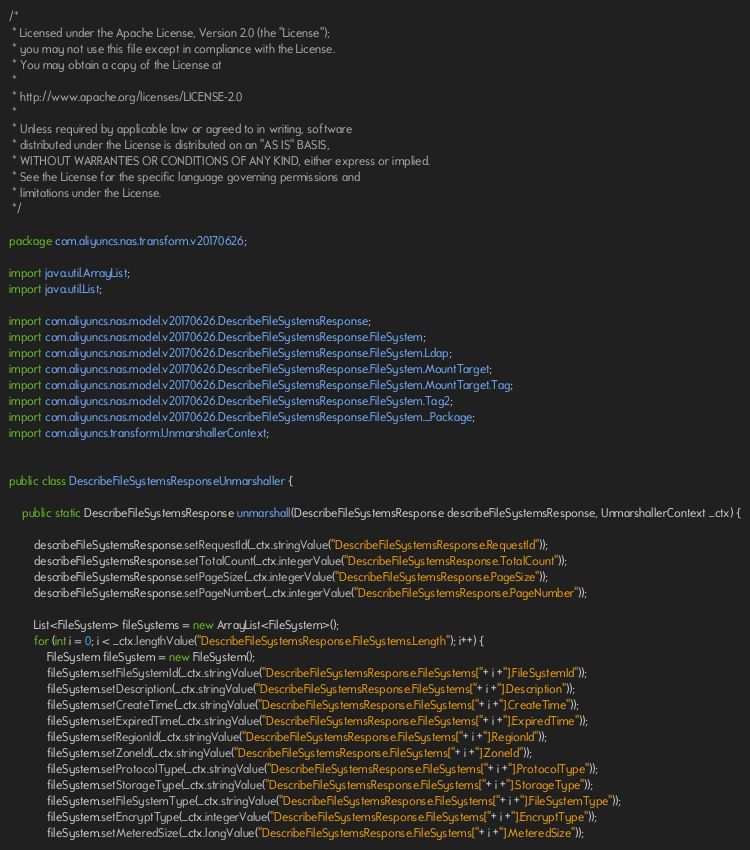Convert code to text. <code><loc_0><loc_0><loc_500><loc_500><_Java_>/*
 * Licensed under the Apache License, Version 2.0 (the "License");
 * you may not use this file except in compliance with the License.
 * You may obtain a copy of the License at
 *
 * http://www.apache.org/licenses/LICENSE-2.0
 *
 * Unless required by applicable law or agreed to in writing, software
 * distributed under the License is distributed on an "AS IS" BASIS,
 * WITHOUT WARRANTIES OR CONDITIONS OF ANY KIND, either express or implied.
 * See the License for the specific language governing permissions and
 * limitations under the License.
 */

package com.aliyuncs.nas.transform.v20170626;

import java.util.ArrayList;
import java.util.List;

import com.aliyuncs.nas.model.v20170626.DescribeFileSystemsResponse;
import com.aliyuncs.nas.model.v20170626.DescribeFileSystemsResponse.FileSystem;
import com.aliyuncs.nas.model.v20170626.DescribeFileSystemsResponse.FileSystem.Ldap;
import com.aliyuncs.nas.model.v20170626.DescribeFileSystemsResponse.FileSystem.MountTarget;
import com.aliyuncs.nas.model.v20170626.DescribeFileSystemsResponse.FileSystem.MountTarget.Tag;
import com.aliyuncs.nas.model.v20170626.DescribeFileSystemsResponse.FileSystem.Tag2;
import com.aliyuncs.nas.model.v20170626.DescribeFileSystemsResponse.FileSystem._Package;
import com.aliyuncs.transform.UnmarshallerContext;


public class DescribeFileSystemsResponseUnmarshaller {

	public static DescribeFileSystemsResponse unmarshall(DescribeFileSystemsResponse describeFileSystemsResponse, UnmarshallerContext _ctx) {
		
		describeFileSystemsResponse.setRequestId(_ctx.stringValue("DescribeFileSystemsResponse.RequestId"));
		describeFileSystemsResponse.setTotalCount(_ctx.integerValue("DescribeFileSystemsResponse.TotalCount"));
		describeFileSystemsResponse.setPageSize(_ctx.integerValue("DescribeFileSystemsResponse.PageSize"));
		describeFileSystemsResponse.setPageNumber(_ctx.integerValue("DescribeFileSystemsResponse.PageNumber"));

		List<FileSystem> fileSystems = new ArrayList<FileSystem>();
		for (int i = 0; i < _ctx.lengthValue("DescribeFileSystemsResponse.FileSystems.Length"); i++) {
			FileSystem fileSystem = new FileSystem();
			fileSystem.setFileSystemId(_ctx.stringValue("DescribeFileSystemsResponse.FileSystems["+ i +"].FileSystemId"));
			fileSystem.setDescription(_ctx.stringValue("DescribeFileSystemsResponse.FileSystems["+ i +"].Description"));
			fileSystem.setCreateTime(_ctx.stringValue("DescribeFileSystemsResponse.FileSystems["+ i +"].CreateTime"));
			fileSystem.setExpiredTime(_ctx.stringValue("DescribeFileSystemsResponse.FileSystems["+ i +"].ExpiredTime"));
			fileSystem.setRegionId(_ctx.stringValue("DescribeFileSystemsResponse.FileSystems["+ i +"].RegionId"));
			fileSystem.setZoneId(_ctx.stringValue("DescribeFileSystemsResponse.FileSystems["+ i +"].ZoneId"));
			fileSystem.setProtocolType(_ctx.stringValue("DescribeFileSystemsResponse.FileSystems["+ i +"].ProtocolType"));
			fileSystem.setStorageType(_ctx.stringValue("DescribeFileSystemsResponse.FileSystems["+ i +"].StorageType"));
			fileSystem.setFileSystemType(_ctx.stringValue("DescribeFileSystemsResponse.FileSystems["+ i +"].FileSystemType"));
			fileSystem.setEncryptType(_ctx.integerValue("DescribeFileSystemsResponse.FileSystems["+ i +"].EncryptType"));
			fileSystem.setMeteredSize(_ctx.longValue("DescribeFileSystemsResponse.FileSystems["+ i +"].MeteredSize"));</code> 